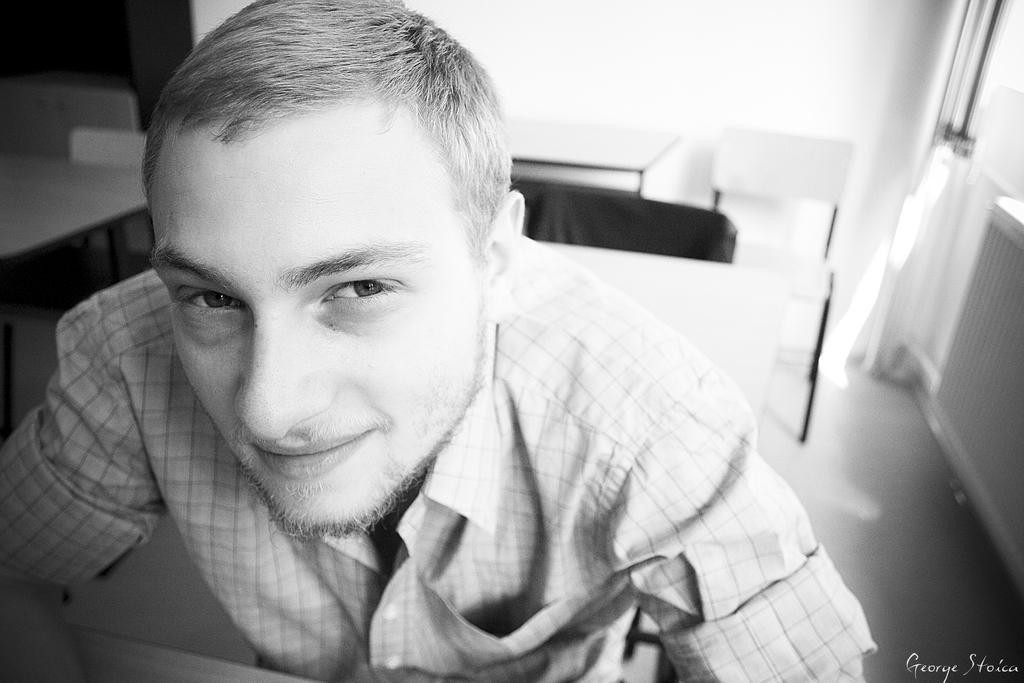Who is present in the image? There is a man in the image. What is the man wearing? The man is wearing a shirt. What expression does the man have on his face? The man has a smile on his face. What is the color scheme of the image? The image is black and white in color. Is there any additional information or markings in the image? Yes, there is a watermark in the image. Can you tell me how many times the man is taking a bath in the image? There is no indication of the man taking a bath in the image, as he is wearing a shirt and the image is black and white. 